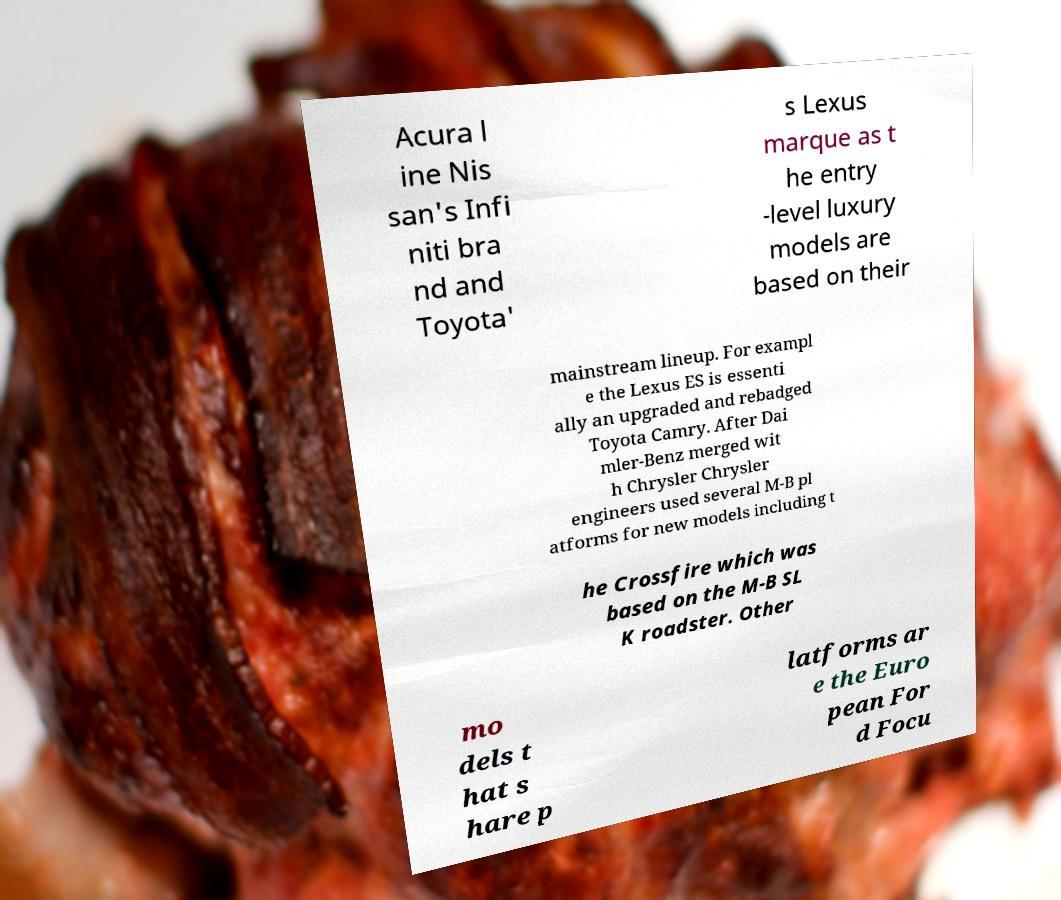Could you assist in decoding the text presented in this image and type it out clearly? Acura l ine Nis san's Infi niti bra nd and Toyota' s Lexus marque as t he entry -level luxury models are based on their mainstream lineup. For exampl e the Lexus ES is essenti ally an upgraded and rebadged Toyota Camry. After Dai mler-Benz merged wit h Chrysler Chrysler engineers used several M-B pl atforms for new models including t he Crossfire which was based on the M-B SL K roadster. Other mo dels t hat s hare p latforms ar e the Euro pean For d Focu 